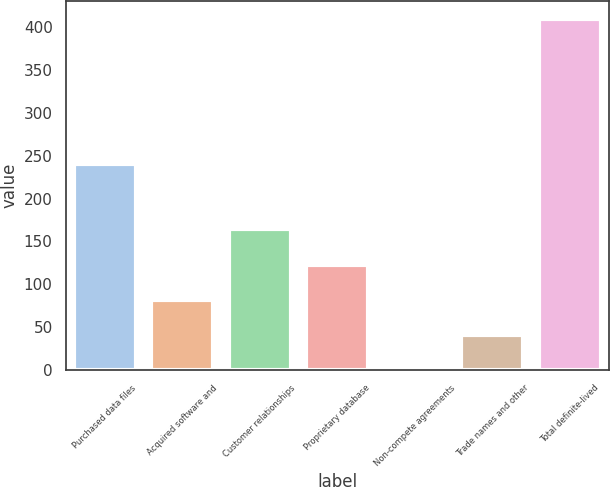<chart> <loc_0><loc_0><loc_500><loc_500><bar_chart><fcel>Purchased data files<fcel>Acquired software and<fcel>Customer relationships<fcel>Proprietary database<fcel>Non-compete agreements<fcel>Trade names and other<fcel>Total definite-lived<nl><fcel>240.6<fcel>82.28<fcel>164.06<fcel>123.17<fcel>0.5<fcel>41.39<fcel>409.4<nl></chart> 